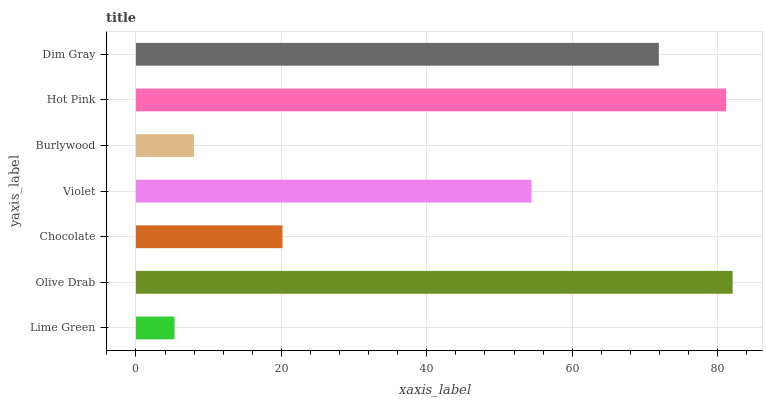Is Lime Green the minimum?
Answer yes or no. Yes. Is Olive Drab the maximum?
Answer yes or no. Yes. Is Chocolate the minimum?
Answer yes or no. No. Is Chocolate the maximum?
Answer yes or no. No. Is Olive Drab greater than Chocolate?
Answer yes or no. Yes. Is Chocolate less than Olive Drab?
Answer yes or no. Yes. Is Chocolate greater than Olive Drab?
Answer yes or no. No. Is Olive Drab less than Chocolate?
Answer yes or no. No. Is Violet the high median?
Answer yes or no. Yes. Is Violet the low median?
Answer yes or no. Yes. Is Olive Drab the high median?
Answer yes or no. No. Is Hot Pink the low median?
Answer yes or no. No. 